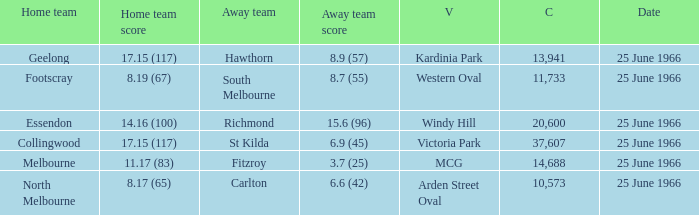When a home team scored 17.15 (117) and the away team scored 6.9 (45), what was the away team? St Kilda. 